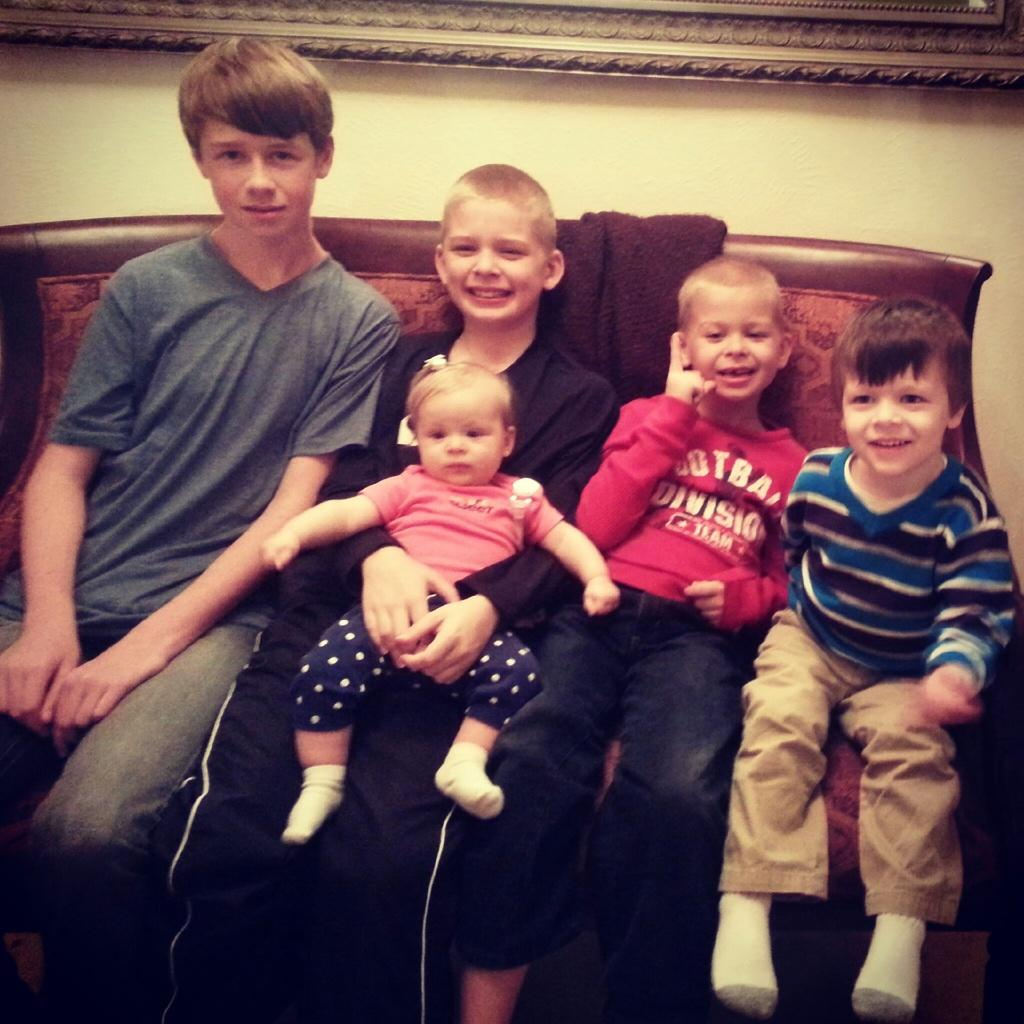How many boys are present in the image? There are four boys in the image. What are the boys doing in the image? The boys are sitting on a sofa. Is there anyone else in the image besides the boys? Yes, one of the boys is holding a baby. How does the boy holding the baby appear to feel? The boy holding the baby has a smile on his face, suggesting he is happy. What type of amusement park can be seen in the background of the image? There is no amusement park visible in the image; it only shows the boys sitting on a sofa. 